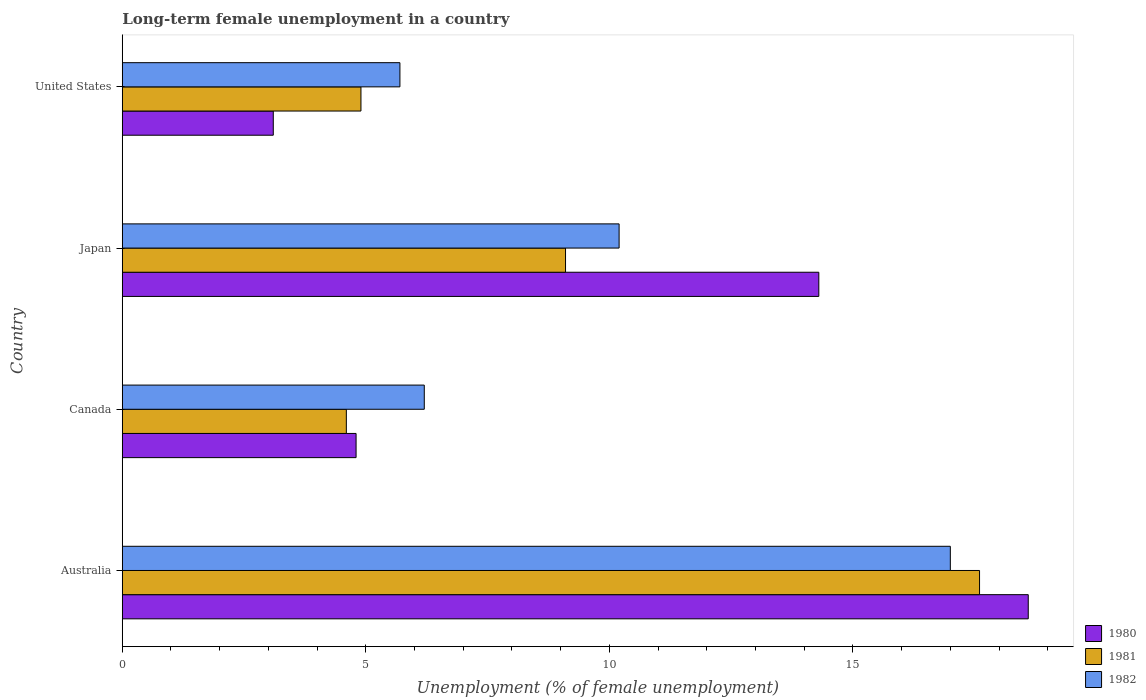How many different coloured bars are there?
Offer a terse response. 3. How many groups of bars are there?
Your answer should be very brief. 4. Are the number of bars on each tick of the Y-axis equal?
Your answer should be compact. Yes. How many bars are there on the 4th tick from the top?
Offer a very short reply. 3. What is the label of the 4th group of bars from the top?
Your answer should be very brief. Australia. What is the percentage of long-term unemployed female population in 1980 in United States?
Ensure brevity in your answer.  3.1. Across all countries, what is the maximum percentage of long-term unemployed female population in 1982?
Give a very brief answer. 17. Across all countries, what is the minimum percentage of long-term unemployed female population in 1980?
Your response must be concise. 3.1. In which country was the percentage of long-term unemployed female population in 1981 maximum?
Offer a terse response. Australia. In which country was the percentage of long-term unemployed female population in 1980 minimum?
Keep it short and to the point. United States. What is the total percentage of long-term unemployed female population in 1982 in the graph?
Ensure brevity in your answer.  39.1. What is the difference between the percentage of long-term unemployed female population in 1981 in Australia and that in Canada?
Give a very brief answer. 13. What is the difference between the percentage of long-term unemployed female population in 1980 in Japan and the percentage of long-term unemployed female population in 1982 in Australia?
Give a very brief answer. -2.7. What is the average percentage of long-term unemployed female population in 1980 per country?
Provide a short and direct response. 10.2. What is the difference between the percentage of long-term unemployed female population in 1982 and percentage of long-term unemployed female population in 1980 in United States?
Keep it short and to the point. 2.6. In how many countries, is the percentage of long-term unemployed female population in 1980 greater than 4 %?
Your answer should be very brief. 3. What is the ratio of the percentage of long-term unemployed female population in 1981 in Australia to that in United States?
Your answer should be compact. 3.59. Is the percentage of long-term unemployed female population in 1980 in Australia less than that in United States?
Offer a very short reply. No. Is the difference between the percentage of long-term unemployed female population in 1982 in Australia and Japan greater than the difference between the percentage of long-term unemployed female population in 1980 in Australia and Japan?
Offer a very short reply. Yes. What is the difference between the highest and the second highest percentage of long-term unemployed female population in 1981?
Give a very brief answer. 8.5. What is the difference between the highest and the lowest percentage of long-term unemployed female population in 1982?
Ensure brevity in your answer.  11.3. What does the 1st bar from the top in Japan represents?
Your response must be concise. 1982. Is it the case that in every country, the sum of the percentage of long-term unemployed female population in 1981 and percentage of long-term unemployed female population in 1980 is greater than the percentage of long-term unemployed female population in 1982?
Your response must be concise. Yes. Are all the bars in the graph horizontal?
Give a very brief answer. Yes. Does the graph contain grids?
Ensure brevity in your answer.  No. What is the title of the graph?
Your response must be concise. Long-term female unemployment in a country. What is the label or title of the X-axis?
Provide a short and direct response. Unemployment (% of female unemployment). What is the Unemployment (% of female unemployment) of 1980 in Australia?
Make the answer very short. 18.6. What is the Unemployment (% of female unemployment) of 1981 in Australia?
Provide a short and direct response. 17.6. What is the Unemployment (% of female unemployment) of 1980 in Canada?
Provide a succinct answer. 4.8. What is the Unemployment (% of female unemployment) in 1981 in Canada?
Ensure brevity in your answer.  4.6. What is the Unemployment (% of female unemployment) of 1982 in Canada?
Ensure brevity in your answer.  6.2. What is the Unemployment (% of female unemployment) of 1980 in Japan?
Offer a very short reply. 14.3. What is the Unemployment (% of female unemployment) of 1981 in Japan?
Offer a very short reply. 9.1. What is the Unemployment (% of female unemployment) of 1982 in Japan?
Your response must be concise. 10.2. What is the Unemployment (% of female unemployment) of 1980 in United States?
Offer a very short reply. 3.1. What is the Unemployment (% of female unemployment) of 1981 in United States?
Your answer should be compact. 4.9. What is the Unemployment (% of female unemployment) in 1982 in United States?
Your response must be concise. 5.7. Across all countries, what is the maximum Unemployment (% of female unemployment) in 1980?
Offer a very short reply. 18.6. Across all countries, what is the maximum Unemployment (% of female unemployment) in 1981?
Your answer should be very brief. 17.6. Across all countries, what is the minimum Unemployment (% of female unemployment) in 1980?
Ensure brevity in your answer.  3.1. Across all countries, what is the minimum Unemployment (% of female unemployment) of 1981?
Your response must be concise. 4.6. Across all countries, what is the minimum Unemployment (% of female unemployment) in 1982?
Offer a terse response. 5.7. What is the total Unemployment (% of female unemployment) of 1980 in the graph?
Ensure brevity in your answer.  40.8. What is the total Unemployment (% of female unemployment) of 1981 in the graph?
Offer a very short reply. 36.2. What is the total Unemployment (% of female unemployment) in 1982 in the graph?
Your response must be concise. 39.1. What is the difference between the Unemployment (% of female unemployment) in 1982 in Australia and that in Canada?
Make the answer very short. 10.8. What is the difference between the Unemployment (% of female unemployment) of 1981 in Australia and that in Japan?
Give a very brief answer. 8.5. What is the difference between the Unemployment (% of female unemployment) in 1980 in Australia and that in United States?
Provide a succinct answer. 15.5. What is the difference between the Unemployment (% of female unemployment) of 1981 in Australia and that in United States?
Your answer should be compact. 12.7. What is the difference between the Unemployment (% of female unemployment) in 1982 in Australia and that in United States?
Provide a succinct answer. 11.3. What is the difference between the Unemployment (% of female unemployment) of 1980 in Canada and that in Japan?
Make the answer very short. -9.5. What is the difference between the Unemployment (% of female unemployment) of 1982 in Canada and that in Japan?
Ensure brevity in your answer.  -4. What is the difference between the Unemployment (% of female unemployment) in 1980 in Canada and that in United States?
Provide a succinct answer. 1.7. What is the difference between the Unemployment (% of female unemployment) in 1980 in Japan and that in United States?
Ensure brevity in your answer.  11.2. What is the difference between the Unemployment (% of female unemployment) of 1981 in Japan and that in United States?
Offer a terse response. 4.2. What is the difference between the Unemployment (% of female unemployment) in 1980 in Australia and the Unemployment (% of female unemployment) in 1981 in Canada?
Ensure brevity in your answer.  14. What is the difference between the Unemployment (% of female unemployment) in 1981 in Australia and the Unemployment (% of female unemployment) in 1982 in Canada?
Offer a very short reply. 11.4. What is the difference between the Unemployment (% of female unemployment) in 1980 in Australia and the Unemployment (% of female unemployment) in 1981 in Japan?
Keep it short and to the point. 9.5. What is the difference between the Unemployment (% of female unemployment) of 1980 in Australia and the Unemployment (% of female unemployment) of 1982 in Japan?
Provide a succinct answer. 8.4. What is the difference between the Unemployment (% of female unemployment) in 1981 in Australia and the Unemployment (% of female unemployment) in 1982 in Japan?
Provide a short and direct response. 7.4. What is the difference between the Unemployment (% of female unemployment) of 1980 in Australia and the Unemployment (% of female unemployment) of 1982 in United States?
Offer a very short reply. 12.9. What is the difference between the Unemployment (% of female unemployment) in 1980 in Japan and the Unemployment (% of female unemployment) in 1981 in United States?
Give a very brief answer. 9.4. What is the difference between the Unemployment (% of female unemployment) of 1981 in Japan and the Unemployment (% of female unemployment) of 1982 in United States?
Provide a short and direct response. 3.4. What is the average Unemployment (% of female unemployment) in 1980 per country?
Give a very brief answer. 10.2. What is the average Unemployment (% of female unemployment) in 1981 per country?
Provide a succinct answer. 9.05. What is the average Unemployment (% of female unemployment) in 1982 per country?
Provide a short and direct response. 9.78. What is the difference between the Unemployment (% of female unemployment) of 1980 and Unemployment (% of female unemployment) of 1981 in Australia?
Ensure brevity in your answer.  1. What is the difference between the Unemployment (% of female unemployment) of 1980 and Unemployment (% of female unemployment) of 1982 in Australia?
Make the answer very short. 1.6. What is the difference between the Unemployment (% of female unemployment) of 1980 and Unemployment (% of female unemployment) of 1981 in Canada?
Your response must be concise. 0.2. What is the difference between the Unemployment (% of female unemployment) in 1980 and Unemployment (% of female unemployment) in 1982 in Canada?
Your answer should be compact. -1.4. What is the difference between the Unemployment (% of female unemployment) in 1981 and Unemployment (% of female unemployment) in 1982 in Canada?
Your response must be concise. -1.6. What is the difference between the Unemployment (% of female unemployment) of 1980 and Unemployment (% of female unemployment) of 1981 in Japan?
Give a very brief answer. 5.2. What is the difference between the Unemployment (% of female unemployment) in 1981 and Unemployment (% of female unemployment) in 1982 in United States?
Provide a succinct answer. -0.8. What is the ratio of the Unemployment (% of female unemployment) in 1980 in Australia to that in Canada?
Ensure brevity in your answer.  3.88. What is the ratio of the Unemployment (% of female unemployment) of 1981 in Australia to that in Canada?
Your answer should be very brief. 3.83. What is the ratio of the Unemployment (% of female unemployment) in 1982 in Australia to that in Canada?
Give a very brief answer. 2.74. What is the ratio of the Unemployment (% of female unemployment) in 1980 in Australia to that in Japan?
Ensure brevity in your answer.  1.3. What is the ratio of the Unemployment (% of female unemployment) of 1981 in Australia to that in Japan?
Offer a terse response. 1.93. What is the ratio of the Unemployment (% of female unemployment) of 1982 in Australia to that in Japan?
Your answer should be compact. 1.67. What is the ratio of the Unemployment (% of female unemployment) of 1980 in Australia to that in United States?
Your response must be concise. 6. What is the ratio of the Unemployment (% of female unemployment) in 1981 in Australia to that in United States?
Your answer should be compact. 3.59. What is the ratio of the Unemployment (% of female unemployment) in 1982 in Australia to that in United States?
Provide a succinct answer. 2.98. What is the ratio of the Unemployment (% of female unemployment) in 1980 in Canada to that in Japan?
Offer a very short reply. 0.34. What is the ratio of the Unemployment (% of female unemployment) in 1981 in Canada to that in Japan?
Ensure brevity in your answer.  0.51. What is the ratio of the Unemployment (% of female unemployment) in 1982 in Canada to that in Japan?
Offer a very short reply. 0.61. What is the ratio of the Unemployment (% of female unemployment) of 1980 in Canada to that in United States?
Offer a terse response. 1.55. What is the ratio of the Unemployment (% of female unemployment) in 1981 in Canada to that in United States?
Your answer should be very brief. 0.94. What is the ratio of the Unemployment (% of female unemployment) of 1982 in Canada to that in United States?
Provide a succinct answer. 1.09. What is the ratio of the Unemployment (% of female unemployment) in 1980 in Japan to that in United States?
Your response must be concise. 4.61. What is the ratio of the Unemployment (% of female unemployment) of 1981 in Japan to that in United States?
Offer a terse response. 1.86. What is the ratio of the Unemployment (% of female unemployment) in 1982 in Japan to that in United States?
Offer a terse response. 1.79. What is the difference between the highest and the second highest Unemployment (% of female unemployment) in 1981?
Provide a succinct answer. 8.5. What is the difference between the highest and the lowest Unemployment (% of female unemployment) in 1980?
Your answer should be compact. 15.5. 